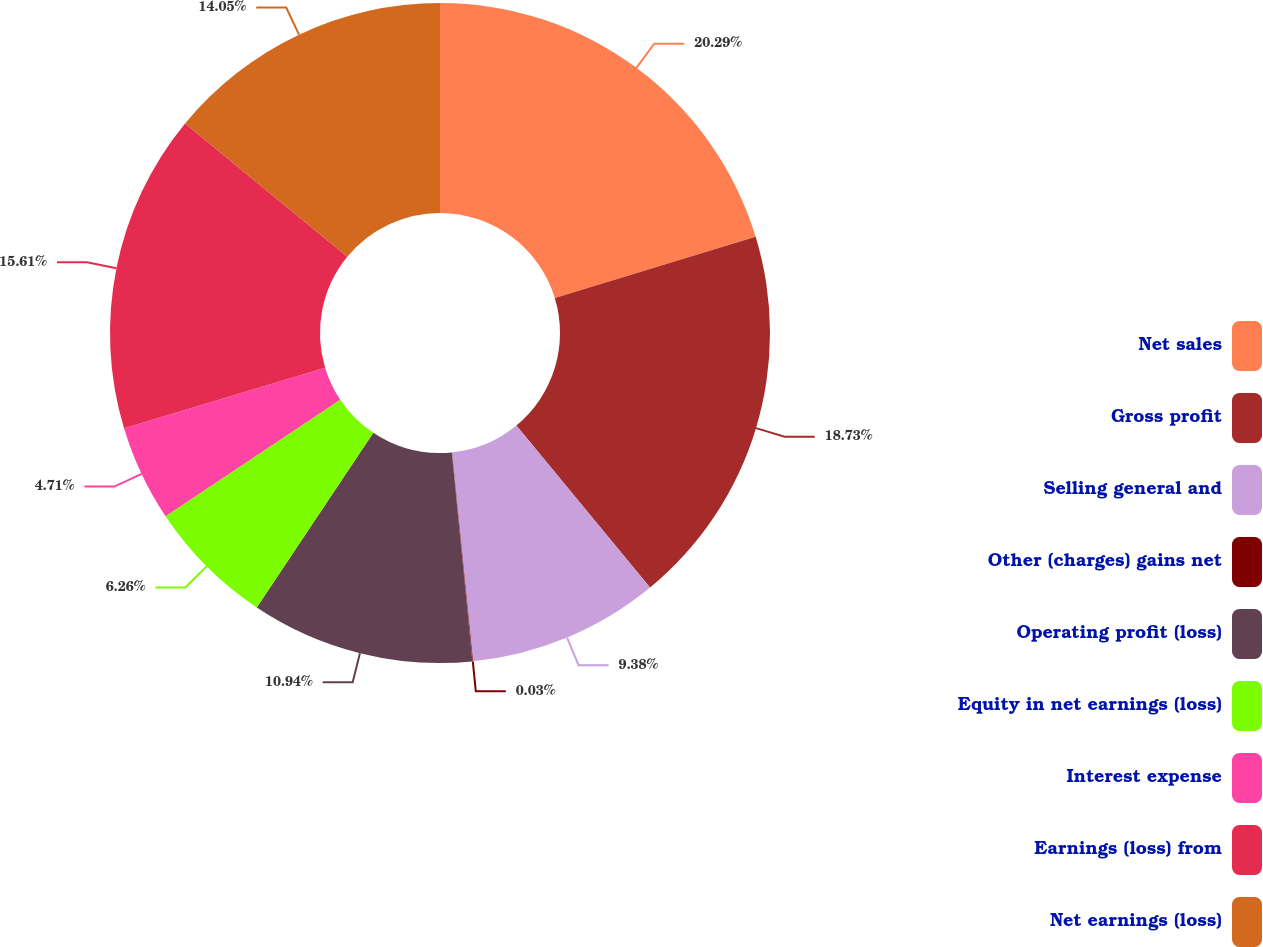Convert chart. <chart><loc_0><loc_0><loc_500><loc_500><pie_chart><fcel>Net sales<fcel>Gross profit<fcel>Selling general and<fcel>Other (charges) gains net<fcel>Operating profit (loss)<fcel>Equity in net earnings (loss)<fcel>Interest expense<fcel>Earnings (loss) from<fcel>Net earnings (loss)<nl><fcel>20.29%<fcel>18.73%<fcel>9.38%<fcel>0.03%<fcel>10.94%<fcel>6.26%<fcel>4.71%<fcel>15.61%<fcel>14.05%<nl></chart> 